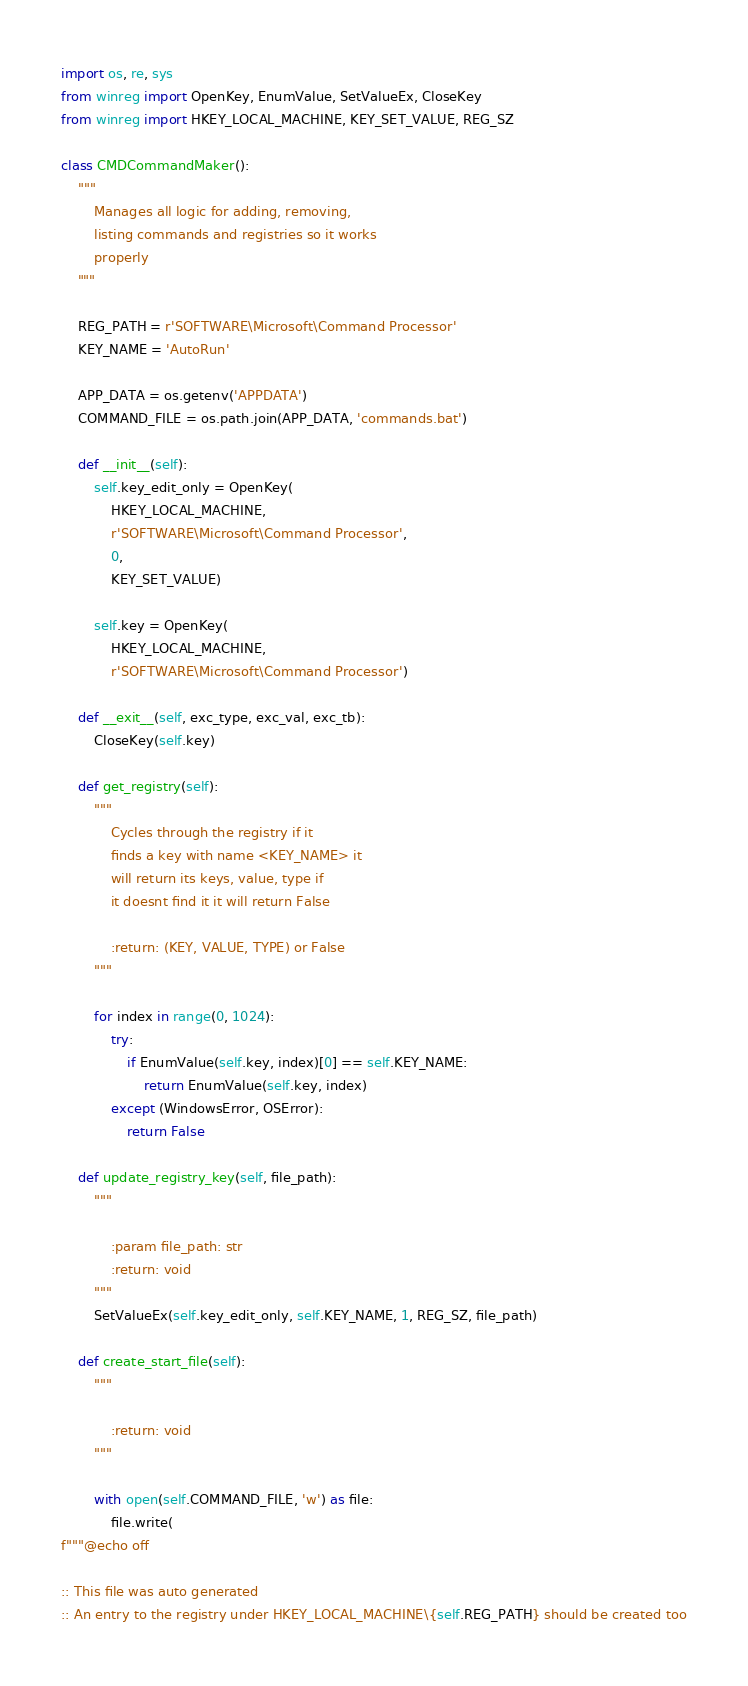<code> <loc_0><loc_0><loc_500><loc_500><_Python_>import os, re, sys
from winreg import OpenKey, EnumValue, SetValueEx, CloseKey
from winreg import HKEY_LOCAL_MACHINE, KEY_SET_VALUE, REG_SZ

class CMDCommandMaker():
    """
        Manages all logic for adding, removing,
        listing commands and registries so it works
        properly
    """

    REG_PATH = r'SOFTWARE\Microsoft\Command Processor'
    KEY_NAME = 'AutoRun'

    APP_DATA = os.getenv('APPDATA')
    COMMAND_FILE = os.path.join(APP_DATA, 'commands.bat')

    def __init__(self):
        self.key_edit_only = OpenKey(
            HKEY_LOCAL_MACHINE,
            r'SOFTWARE\Microsoft\Command Processor',
            0,
            KEY_SET_VALUE)

        self.key = OpenKey(
            HKEY_LOCAL_MACHINE,
            r'SOFTWARE\Microsoft\Command Processor')

    def __exit__(self, exc_type, exc_val, exc_tb):
        CloseKey(self.key)

    def get_registry(self):
        """
            Cycles through the registry if it
            finds a key with name <KEY_NAME> it
            will return its keys, value, type if
            it doesnt find it it will return False

            :return: (KEY, VALUE, TYPE) or False
        """

        for index in range(0, 1024):
            try:
                if EnumValue(self.key, index)[0] == self.KEY_NAME:
                    return EnumValue(self.key, index)
            except (WindowsError, OSError):
                return False

    def update_registry_key(self, file_path):
        """

            :param file_path: str
            :return: void
        """
        SetValueEx(self.key_edit_only, self.KEY_NAME, 1, REG_SZ, file_path)

    def create_start_file(self):
        """

            :return: void
        """

        with open(self.COMMAND_FILE, 'w') as file:
            file.write(
f"""@echo off

:: This file was auto generated
:: An entry to the registry under HKEY_LOCAL_MACHINE\{self.REG_PATH} should be created too
</code> 